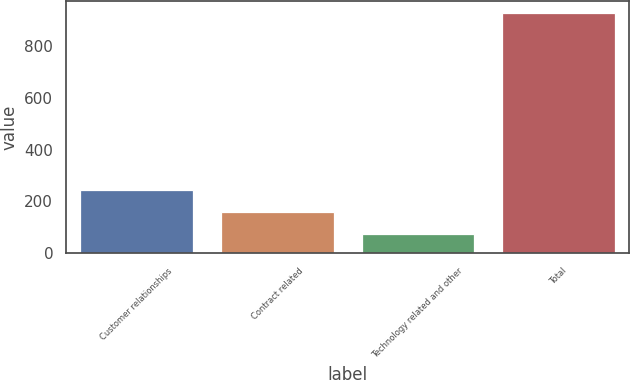Convert chart. <chart><loc_0><loc_0><loc_500><loc_500><bar_chart><fcel>Customer relationships<fcel>Contract related<fcel>Technology related and other<fcel>Total<nl><fcel>244.4<fcel>159.2<fcel>74<fcel>926<nl></chart> 